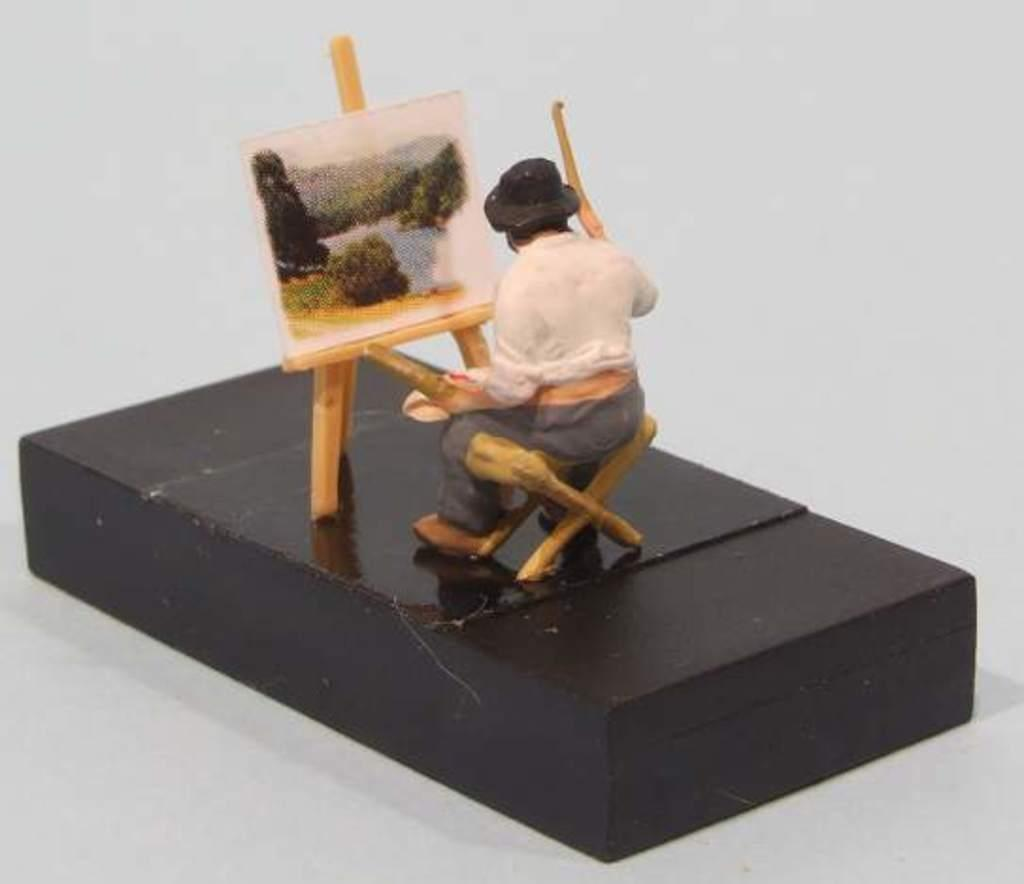What is the main subject of the image? There is a miniature person in the image. What object is the board placed on? The board is on a black object. What color is the background of the image? The background of the image is white. How many screws are visible in the image? There are no screws visible in the image. What type of drain is present in the image? There is no drain present in the image. 